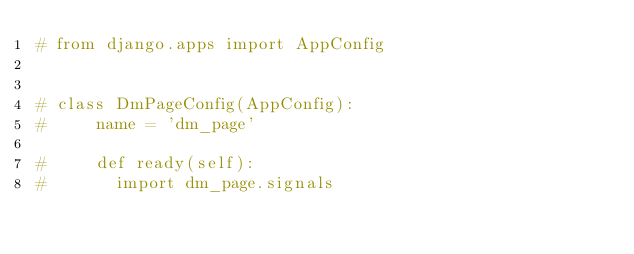<code> <loc_0><loc_0><loc_500><loc_500><_Python_># from django.apps import AppConfig


# class DmPageConfig(AppConfig):
#     name = 'dm_page'

#     def ready(self):
#     	import dm_page.signals
</code> 